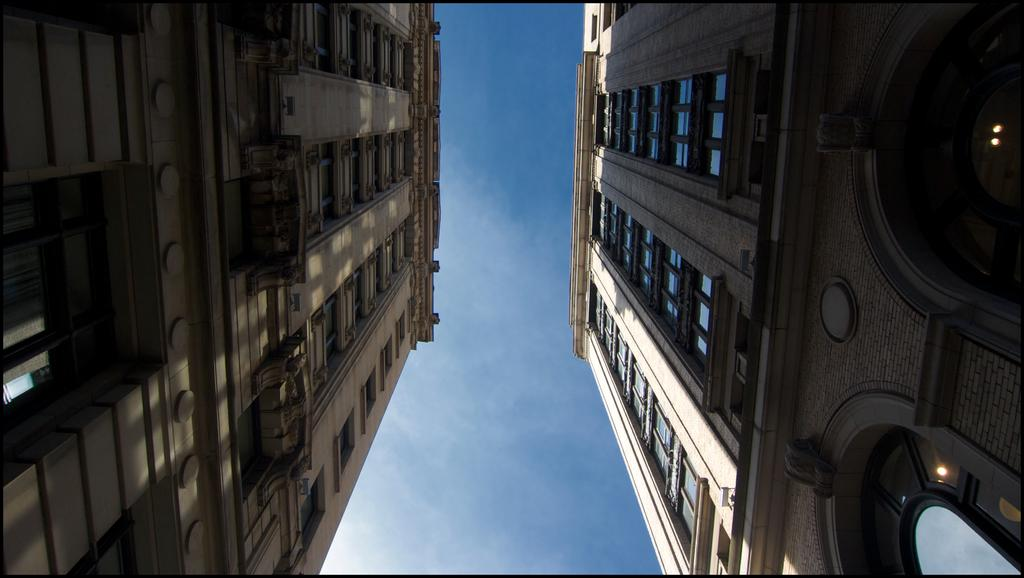How many buildings can be seen in the image? There are two buildings in the image. What can be seen in the background of the image? There are clouds and the sky visible in the background of the image. What type of station can be seen in the image? There is no station present in the image. What impulse is causing the clouds to move in the image? The image is a still photograph, so there is no movement or impulse causing the clouds to move. 